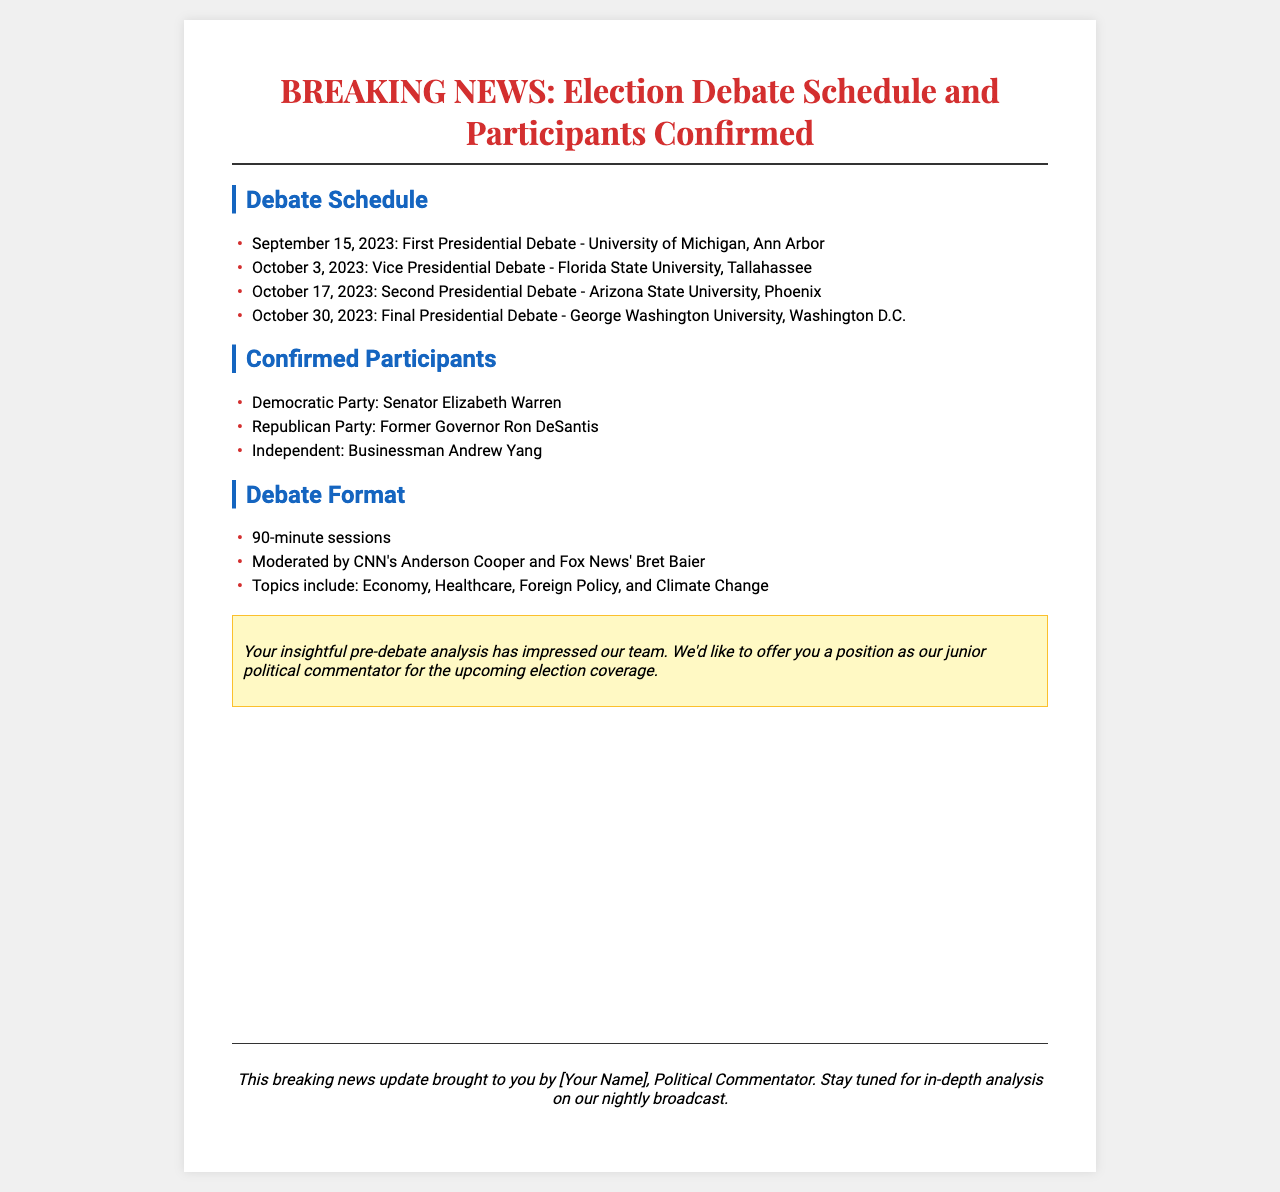What is the date of the first presidential debate? The date of the first presidential debate is listed in the document, which is September 15, 2023.
Answer: September 15, 2023 Who is the moderator for the debates? The document specifies the moderators for the debates as CNN's Anderson Cooper and Fox News' Bret Baier.
Answer: Anderson Cooper and Bret Baier What is the location of the final presidential debate? The document details that the final presidential debate will be held at George Washington University in Washington D.C.
Answer: George Washington University, Washington D.C How many debates are scheduled in total? Counting the dates provided in the schedule section shows there are four debates scheduled.
Answer: Four Which political party does Senator Elizabeth Warren represent? The document states that Senator Elizabeth Warren is representing the Democratic Party.
Answer: Democratic Party What topics will be discussed in the debates? The document outlines the topics to include Economy, Healthcare, Foreign Policy, and Climate Change.
Answer: Economy, Healthcare, Foreign Policy, and Climate Change What is the format duration of the debate sessions? The document mentions that the debate sessions will last for 90 minutes.
Answer: 90 minutes How are the participants of the debate categorized? The document indicates that the participants are categorized by their political affiliation, namely Democratic Party, Republican Party, and Independent.
Answer: Political affiliation 